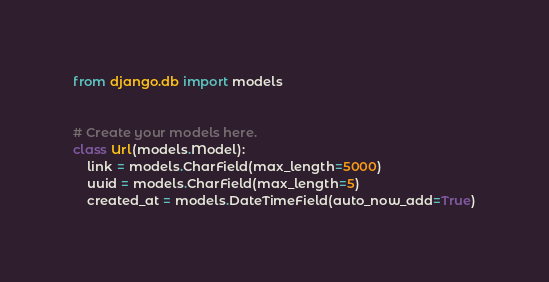<code> <loc_0><loc_0><loc_500><loc_500><_Python_>from django.db import models


# Create your models here.
class Url(models.Model):
    link = models.CharField(max_length=5000)
    uuid = models.CharField(max_length=5)
    created_at = models.DateTimeField(auto_now_add=True)
</code> 